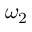Convert formula to latex. <formula><loc_0><loc_0><loc_500><loc_500>\omega _ { 2 }</formula> 